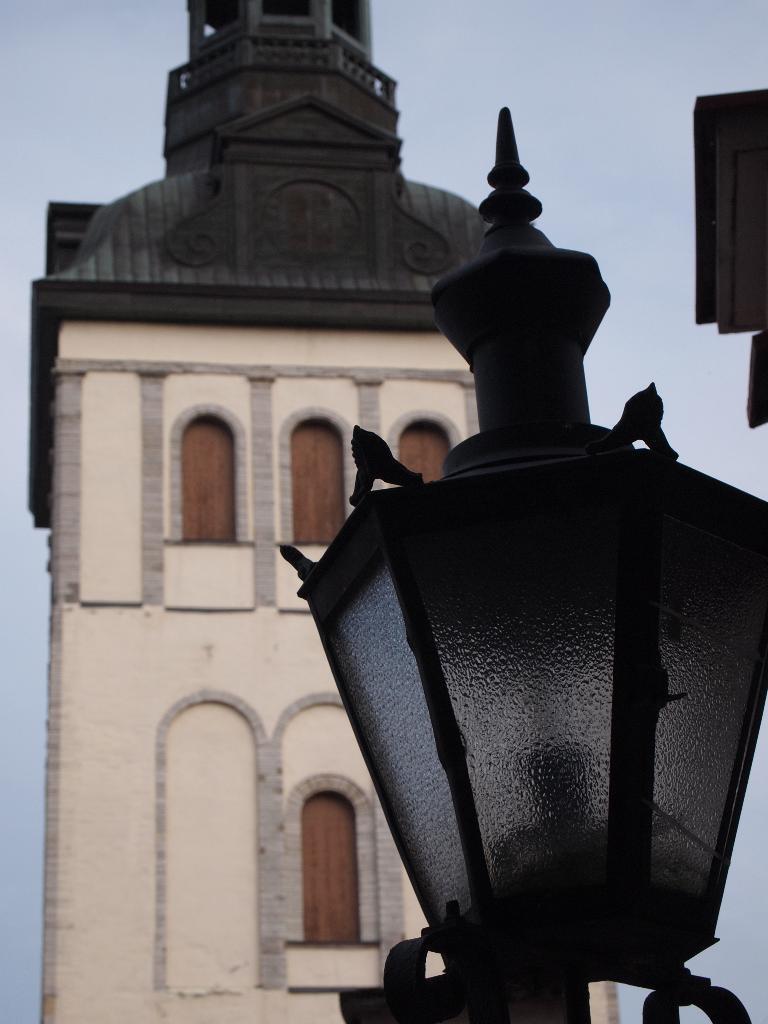Could you give a brief overview of what you see in this image? In this picture I can observe a lamp fixed to the pole on the right side. In the background there is a building and a sky. 